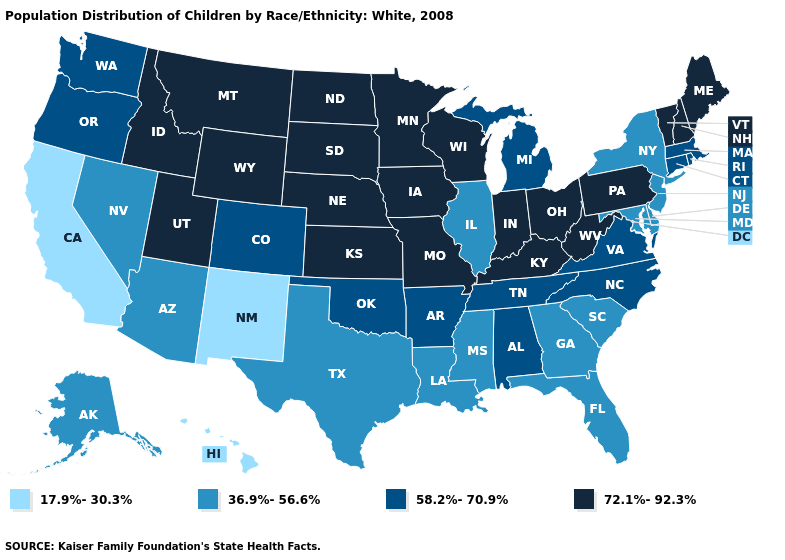Is the legend a continuous bar?
Be succinct. No. What is the lowest value in the USA?
Quick response, please. 17.9%-30.3%. Name the states that have a value in the range 36.9%-56.6%?
Give a very brief answer. Alaska, Arizona, Delaware, Florida, Georgia, Illinois, Louisiana, Maryland, Mississippi, Nevada, New Jersey, New York, South Carolina, Texas. Which states have the lowest value in the USA?
Answer briefly. California, Hawaii, New Mexico. Which states hav the highest value in the South?
Short answer required. Kentucky, West Virginia. Name the states that have a value in the range 17.9%-30.3%?
Short answer required. California, Hawaii, New Mexico. Which states have the highest value in the USA?
Keep it brief. Idaho, Indiana, Iowa, Kansas, Kentucky, Maine, Minnesota, Missouri, Montana, Nebraska, New Hampshire, North Dakota, Ohio, Pennsylvania, South Dakota, Utah, Vermont, West Virginia, Wisconsin, Wyoming. Among the states that border Arkansas , which have the lowest value?
Quick response, please. Louisiana, Mississippi, Texas. What is the value of South Dakota?
Give a very brief answer. 72.1%-92.3%. What is the lowest value in the USA?
Short answer required. 17.9%-30.3%. What is the value of Tennessee?
Short answer required. 58.2%-70.9%. What is the lowest value in the South?
Answer briefly. 36.9%-56.6%. What is the lowest value in the MidWest?
Concise answer only. 36.9%-56.6%. Among the states that border Wisconsin , does Minnesota have the highest value?
Concise answer only. Yes. 